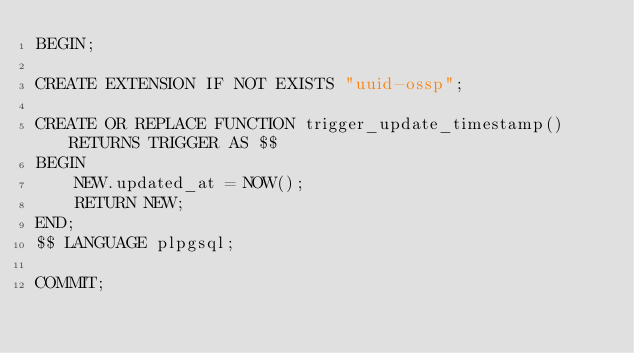Convert code to text. <code><loc_0><loc_0><loc_500><loc_500><_SQL_>BEGIN;

CREATE EXTENSION IF NOT EXISTS "uuid-ossp";

CREATE OR REPLACE FUNCTION trigger_update_timestamp() RETURNS TRIGGER AS $$
BEGIN
    NEW.updated_at = NOW();
    RETURN NEW;
END;
$$ LANGUAGE plpgsql;

COMMIT;
</code> 